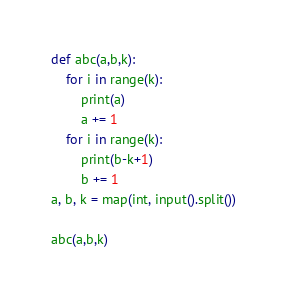Convert code to text. <code><loc_0><loc_0><loc_500><loc_500><_Python_>def abc(a,b,k):
    for i in range(k):
        print(a)
        a += 1
    for i in range(k):
        print(b-k+1)
        b += 1
a, b, k = map(int, input().split())

abc(a,b,k)
</code> 